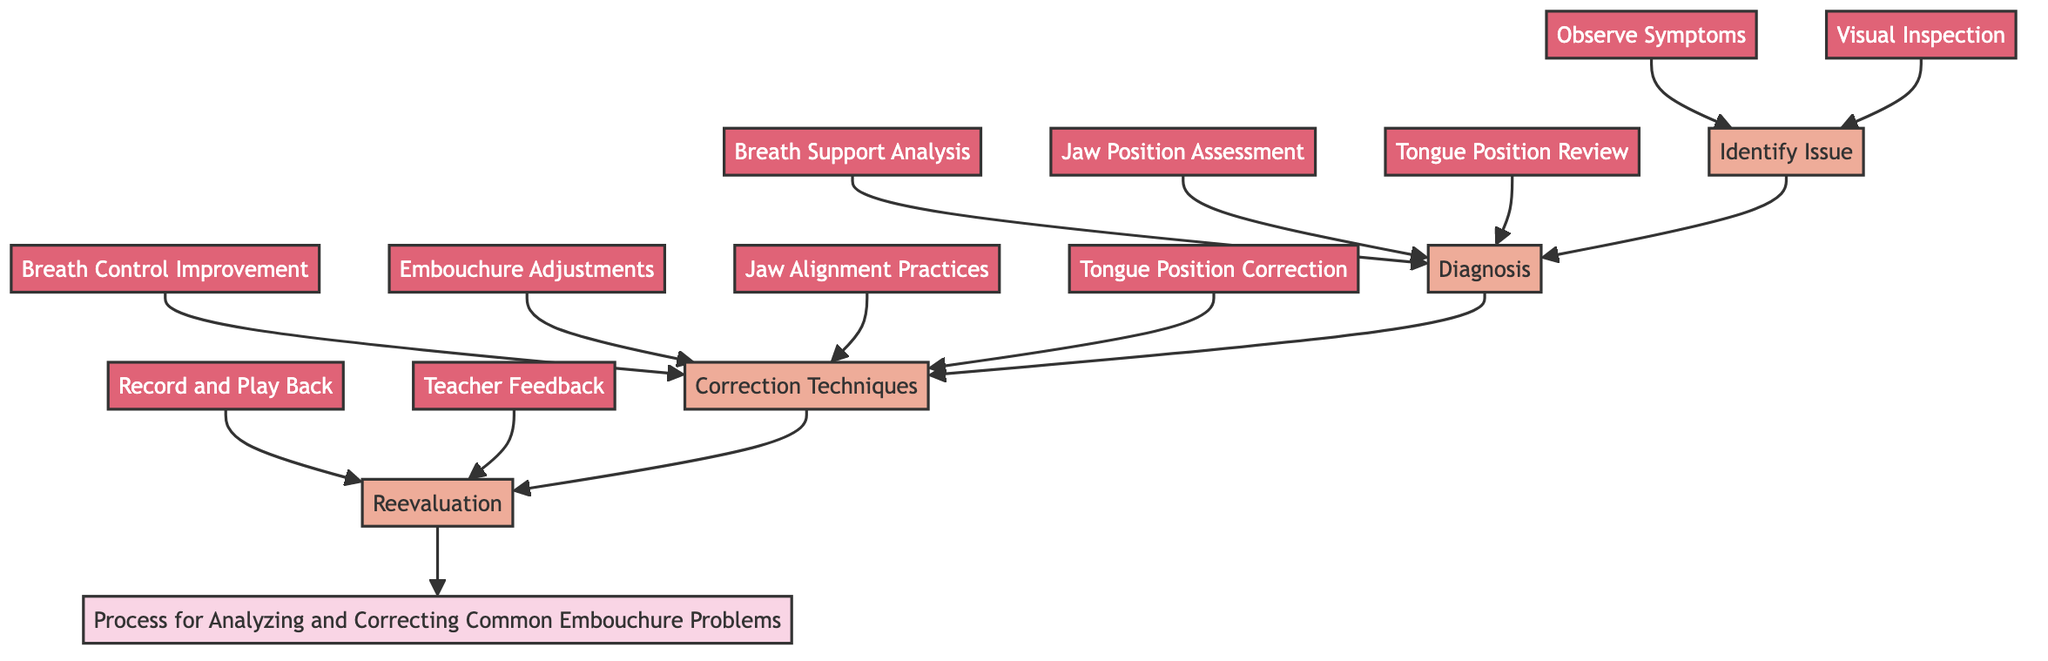What is the first step in the process? The first step is identified at the bottom of the flowchart. It is the "Identify Issue" section, which is where practitioners begin addressing embouchure problems.
Answer: Identify Issue How many correction techniques are listed? By reviewing the "Correction Techniques" node, we see there are four distinct actions listed below it. They are all linked to this section, clearly indicating the number of techniques available.
Answer: 4 What follows the "Diagnosis" step? The "Correction Techniques" node directly follows the "Diagnosis" node in the flow, indicating what actions will be taken after assessing the issues identified earlier.
Answer: Correction Techniques What action is suggested for breath support analysis? Looking at the "Breath Support Analysis" node in the diagnosis section, it suggests evaluating diaphragm engagement and air flow consistency as its primary action for correcting the assessed problem.
Answer: Evaluate diaphragm engagement and air flow consistency What is the relationship between "Embouchure Adjustments" and "Reevaluation"? "Embouchure Adjustments" is part of the "Correction Techniques" that leads back to "Reevaluation," indicating that after making adjustments, the process involves reassessing the effectiveness of those changes.
Answer: Embouchure Adjustments leads to Reevaluation What action is taken after recording and playback? The flow indicates that the action after "Record and Play Back" is to seek "Teacher Feedback," creating a step to validate the corrections made from the recordings.
Answer: Teacher Feedback What is the main purpose of the “Visual Inspection”? From the "Visual Inspection" action in the "Identify Issue" section, the purpose is to check for various physical aspects like improper mouthpiece angle, excessive mouthpiece take-in, and lip compression, emphasizing assessments made visually.
Answer: Assessments made visually How does one proceed after identifying symptoms? After identifying symptoms, the process directs to the "Visual Inspection" step, indicating the need for both audio and visual assessments before moving into diagnosis.
Answer: Visual Inspection 